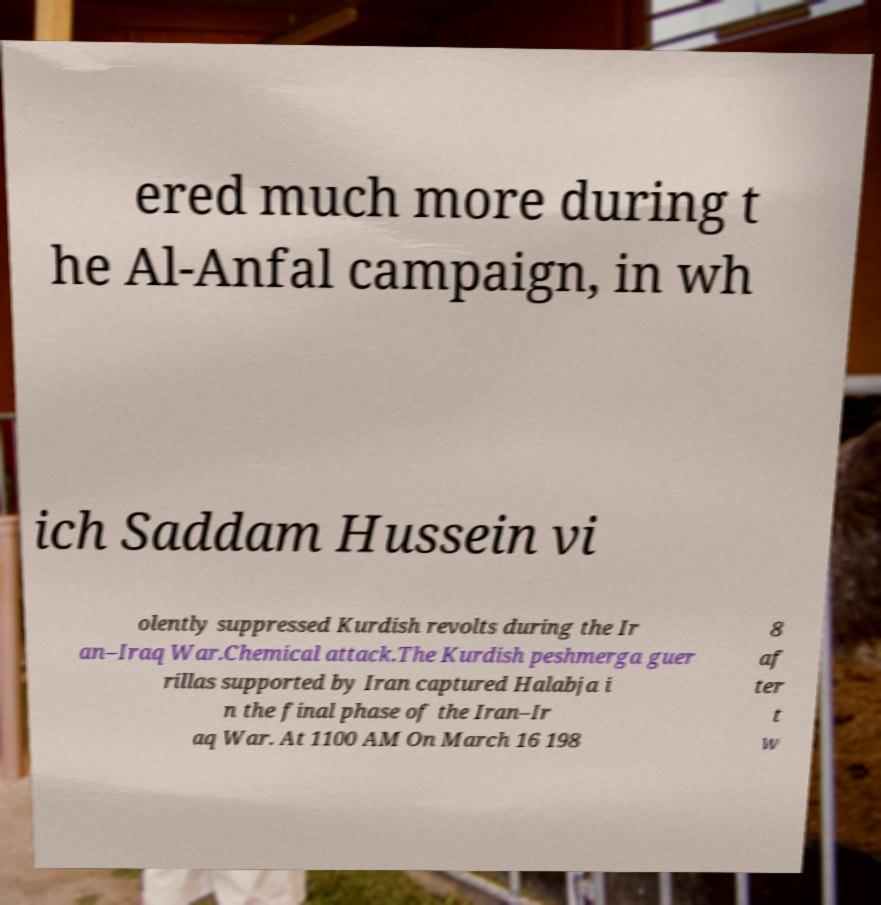I need the written content from this picture converted into text. Can you do that? ered much more during t he Al-Anfal campaign, in wh ich Saddam Hussein vi olently suppressed Kurdish revolts during the Ir an–Iraq War.Chemical attack.The Kurdish peshmerga guer rillas supported by Iran captured Halabja i n the final phase of the Iran–Ir aq War. At 1100 AM On March 16 198 8 af ter t w 